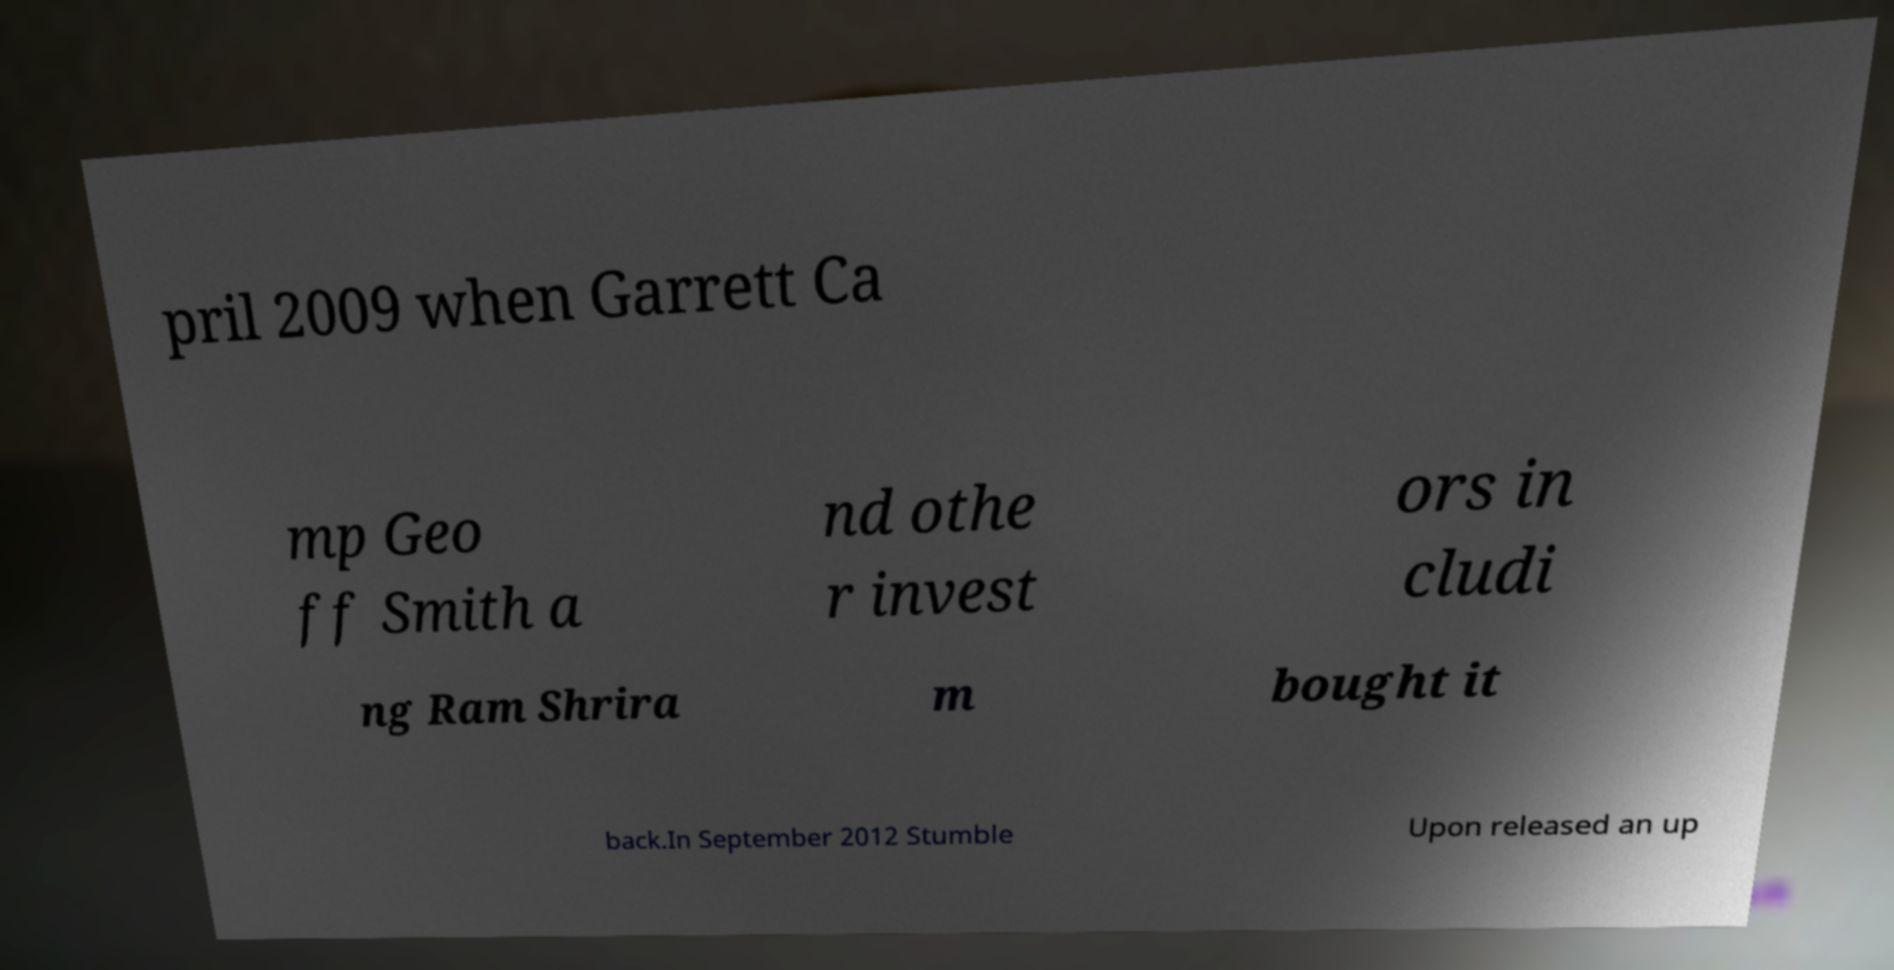Please identify and transcribe the text found in this image. pril 2009 when Garrett Ca mp Geo ff Smith a nd othe r invest ors in cludi ng Ram Shrira m bought it back.In September 2012 Stumble Upon released an up 